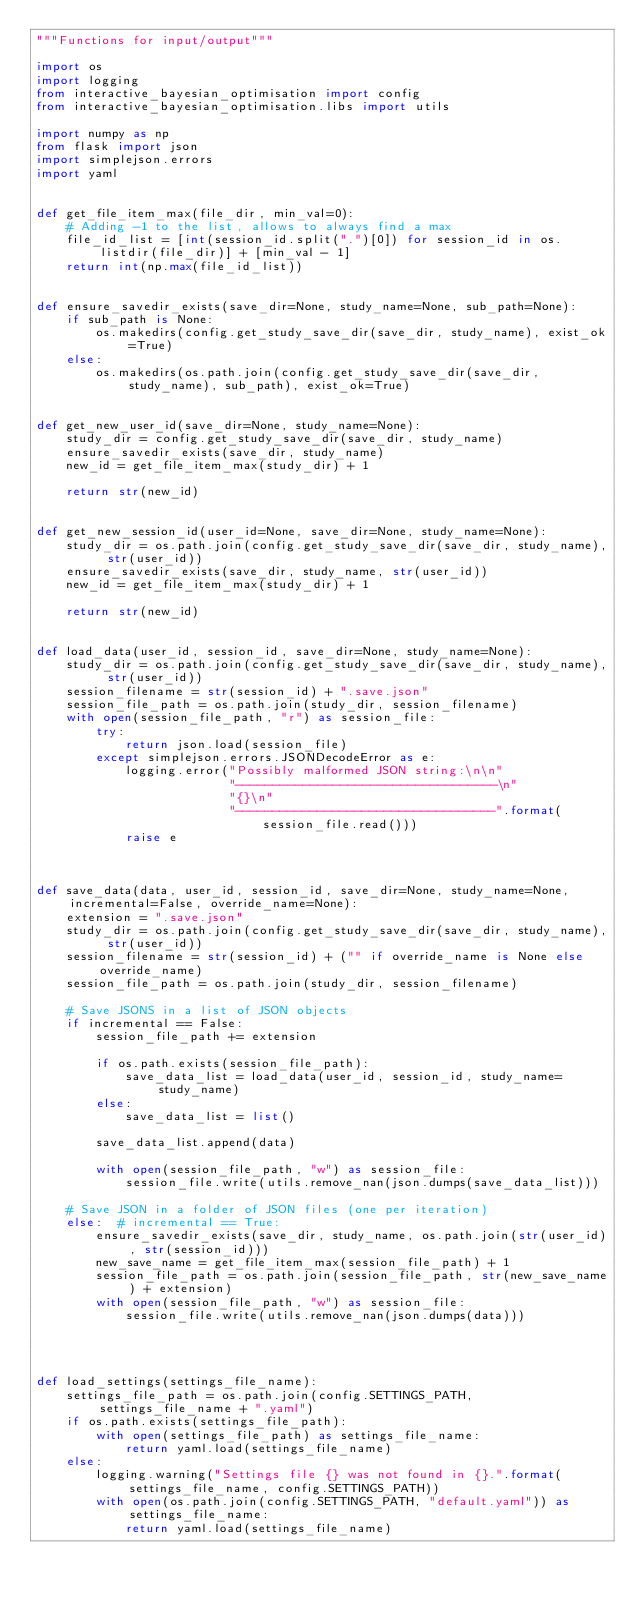<code> <loc_0><loc_0><loc_500><loc_500><_Python_>"""Functions for input/output"""

import os
import logging
from interactive_bayesian_optimisation import config
from interactive_bayesian_optimisation.libs import utils

import numpy as np
from flask import json
import simplejson.errors
import yaml


def get_file_item_max(file_dir, min_val=0):
    # Adding -1 to the list, allows to always find a max
    file_id_list = [int(session_id.split(".")[0]) for session_id in os.listdir(file_dir)] + [min_val - 1]
    return int(np.max(file_id_list))


def ensure_savedir_exists(save_dir=None, study_name=None, sub_path=None):
    if sub_path is None:
        os.makedirs(config.get_study_save_dir(save_dir, study_name), exist_ok=True)
    else:
        os.makedirs(os.path.join(config.get_study_save_dir(save_dir, study_name), sub_path), exist_ok=True)


def get_new_user_id(save_dir=None, study_name=None):
    study_dir = config.get_study_save_dir(save_dir, study_name)
    ensure_savedir_exists(save_dir, study_name)
    new_id = get_file_item_max(study_dir) + 1

    return str(new_id)


def get_new_session_id(user_id=None, save_dir=None, study_name=None):
    study_dir = os.path.join(config.get_study_save_dir(save_dir, study_name), str(user_id))
    ensure_savedir_exists(save_dir, study_name, str(user_id))
    new_id = get_file_item_max(study_dir) + 1

    return str(new_id)


def load_data(user_id, session_id, save_dir=None, study_name=None):
    study_dir = os.path.join(config.get_study_save_dir(save_dir, study_name), str(user_id))
    session_filename = str(session_id) + ".save.json"
    session_file_path = os.path.join(study_dir, session_filename)
    with open(session_file_path, "r") as session_file:
        try:
            return json.load(session_file)
        except simplejson.errors.JSONDecodeError as e:
            logging.error("Possibly malformed JSON string:\n\n"
                          "-----------------------------------\n"
                          "{}\n"
                          "-----------------------------------".format(session_file.read()))
            raise e



def save_data(data, user_id, session_id, save_dir=None, study_name=None, incremental=False, override_name=None):
    extension = ".save.json"
    study_dir = os.path.join(config.get_study_save_dir(save_dir, study_name), str(user_id))
    session_filename = str(session_id) + ("" if override_name is None else override_name)
    session_file_path = os.path.join(study_dir, session_filename)

    # Save JSONS in a list of JSON objects
    if incremental == False:
        session_file_path += extension

        if os.path.exists(session_file_path):
            save_data_list = load_data(user_id, session_id, study_name=study_name)
        else:
            save_data_list = list()

        save_data_list.append(data)

        with open(session_file_path, "w") as session_file:
            session_file.write(utils.remove_nan(json.dumps(save_data_list)))

    # Save JSON in a folder of JSON files (one per iteration)
    else:  # incremental == True:
        ensure_savedir_exists(save_dir, study_name, os.path.join(str(user_id), str(session_id)))
        new_save_name = get_file_item_max(session_file_path) + 1
        session_file_path = os.path.join(session_file_path, str(new_save_name) + extension)
        with open(session_file_path, "w") as session_file:
            session_file.write(utils.remove_nan(json.dumps(data)))




def load_settings(settings_file_name):
    settings_file_path = os.path.join(config.SETTINGS_PATH, settings_file_name + ".yaml")
    if os.path.exists(settings_file_path):
        with open(settings_file_path) as settings_file_name:
            return yaml.load(settings_file_name)
    else:
        logging.warning("Settings file {} was not found in {}.".format(settings_file_name, config.SETTINGS_PATH))
        with open(os.path.join(config.SETTINGS_PATH, "default.yaml")) as settings_file_name:
            return yaml.load(settings_file_name)</code> 